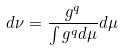Convert formula to latex. <formula><loc_0><loc_0><loc_500><loc_500>d \nu = \frac { g ^ { q } } { \int g ^ { q } d \mu } d \mu</formula> 